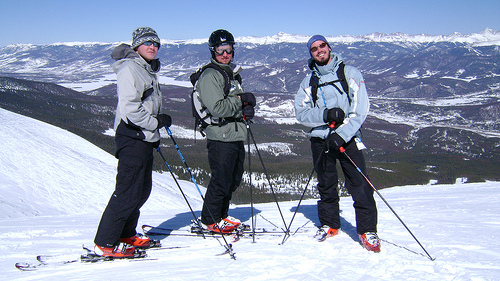Please provide a short description for this region: [0.83, 0.6, 1.0, 0.71]. This area captures a flat expanse of freshly fallen snow, untouched and smooth, reflecting the bright sunlight. 